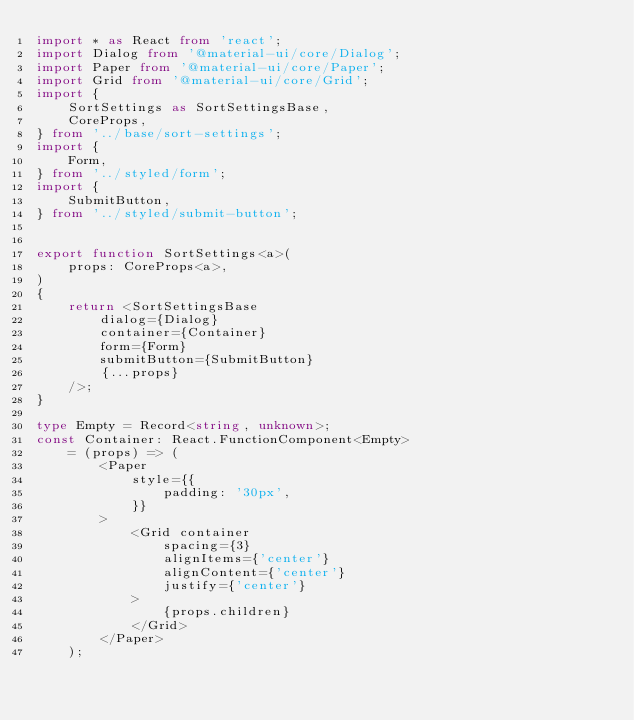Convert code to text. <code><loc_0><loc_0><loc_500><loc_500><_TypeScript_>import * as React from 'react';
import Dialog from '@material-ui/core/Dialog';
import Paper from '@material-ui/core/Paper';
import Grid from '@material-ui/core/Grid';
import {
    SortSettings as SortSettingsBase,
    CoreProps,
} from '../base/sort-settings';
import {
    Form,
} from '../styled/form';
import {
    SubmitButton,
} from '../styled/submit-button';


export function SortSettings<a>(
    props: CoreProps<a>,
)
{
    return <SortSettingsBase
        dialog={Dialog}
        container={Container}
        form={Form}
        submitButton={SubmitButton}
        {...props}
    />;
}

type Empty = Record<string, unknown>;
const Container: React.FunctionComponent<Empty>
    = (props) => (
        <Paper
            style={{
                padding: '30px',
            }}
        >
            <Grid container
                spacing={3}
                alignItems={'center'}
                alignContent={'center'}
                justify={'center'}
            >
                {props.children}
            </Grid>
        </Paper>
    );
</code> 